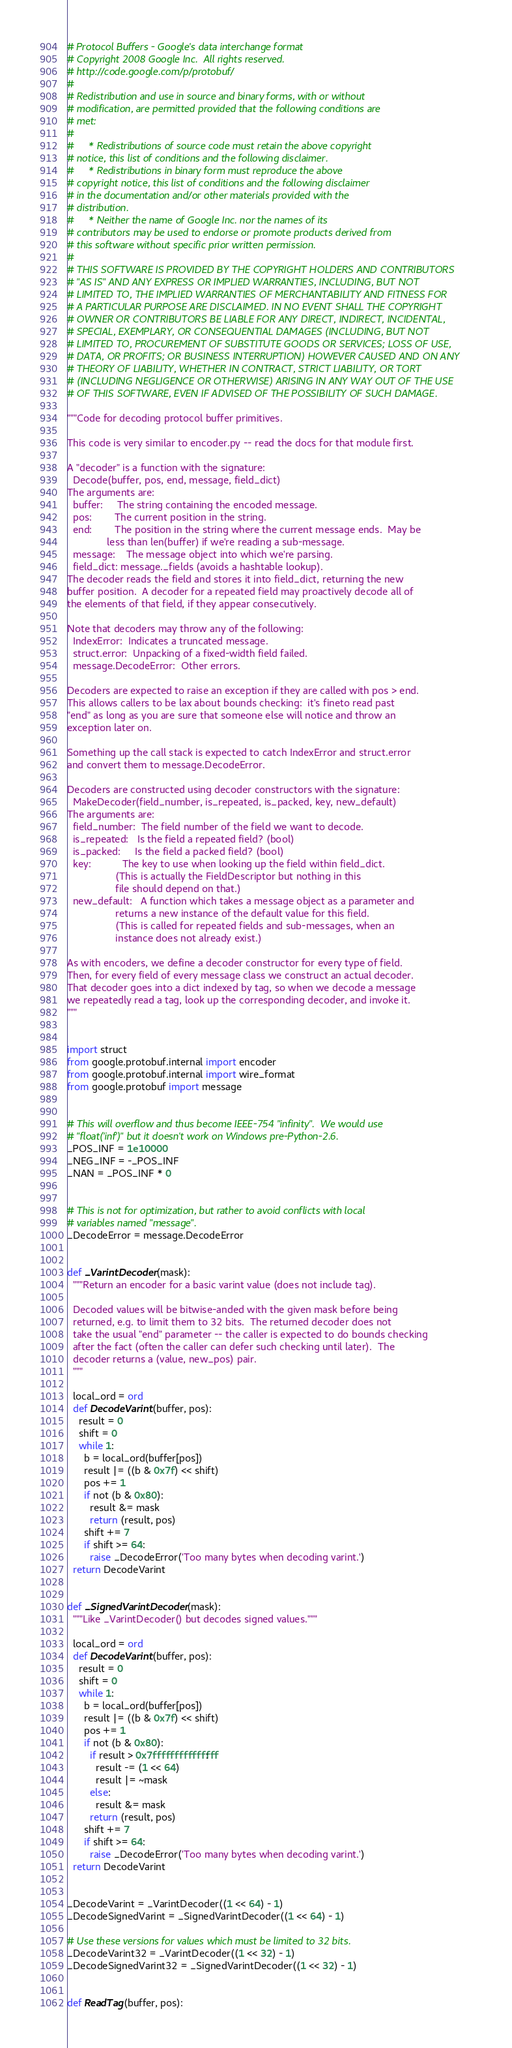Convert code to text. <code><loc_0><loc_0><loc_500><loc_500><_Python_># Protocol Buffers - Google's data interchange format
# Copyright 2008 Google Inc.  All rights reserved.
# http://code.google.com/p/protobuf/
#
# Redistribution and use in source and binary forms, with or without
# modification, are permitted provided that the following conditions are
# met:
#
#     * Redistributions of source code must retain the above copyright
# notice, this list of conditions and the following disclaimer.
#     * Redistributions in binary form must reproduce the above
# copyright notice, this list of conditions and the following disclaimer
# in the documentation and/or other materials provided with the
# distribution.
#     * Neither the name of Google Inc. nor the names of its
# contributors may be used to endorse or promote products derived from
# this software without specific prior written permission.
#
# THIS SOFTWARE IS PROVIDED BY THE COPYRIGHT HOLDERS AND CONTRIBUTORS
# "AS IS" AND ANY EXPRESS OR IMPLIED WARRANTIES, INCLUDING, BUT NOT
# LIMITED TO, THE IMPLIED WARRANTIES OF MERCHANTABILITY AND FITNESS FOR
# A PARTICULAR PURPOSE ARE DISCLAIMED. IN NO EVENT SHALL THE COPYRIGHT
# OWNER OR CONTRIBUTORS BE LIABLE FOR ANY DIRECT, INDIRECT, INCIDENTAL,
# SPECIAL, EXEMPLARY, OR CONSEQUENTIAL DAMAGES (INCLUDING, BUT NOT
# LIMITED TO, PROCUREMENT OF SUBSTITUTE GOODS OR SERVICES; LOSS OF USE,
# DATA, OR PROFITS; OR BUSINESS INTERRUPTION) HOWEVER CAUSED AND ON ANY
# THEORY OF LIABILITY, WHETHER IN CONTRACT, STRICT LIABILITY, OR TORT
# (INCLUDING NEGLIGENCE OR OTHERWISE) ARISING IN ANY WAY OUT OF THE USE
# OF THIS SOFTWARE, EVEN IF ADVISED OF THE POSSIBILITY OF SUCH DAMAGE.

"""Code for decoding protocol buffer primitives.

This code is very similar to encoder.py -- read the docs for that module first.

A "decoder" is a function with the signature:
  Decode(buffer, pos, end, message, field_dict)
The arguments are:
  buffer:     The string containing the encoded message.
  pos:        The current position in the string.
  end:        The position in the string where the current message ends.  May be
              less than len(buffer) if we're reading a sub-message.
  message:    The message object into which we're parsing.
  field_dict: message._fields (avoids a hashtable lookup).
The decoder reads the field and stores it into field_dict, returning the new
buffer position.  A decoder for a repeated field may proactively decode all of
the elements of that field, if they appear consecutively.

Note that decoders may throw any of the following:
  IndexError:  Indicates a truncated message.
  struct.error:  Unpacking of a fixed-width field failed.
  message.DecodeError:  Other errors.

Decoders are expected to raise an exception if they are called with pos > end.
This allows callers to be lax about bounds checking:  it's fineto read past
"end" as long as you are sure that someone else will notice and throw an
exception later on.

Something up the call stack is expected to catch IndexError and struct.error
and convert them to message.DecodeError.

Decoders are constructed using decoder constructors with the signature:
  MakeDecoder(field_number, is_repeated, is_packed, key, new_default)
The arguments are:
  field_number:  The field number of the field we want to decode.
  is_repeated:   Is the field a repeated field? (bool)
  is_packed:     Is the field a packed field? (bool)
  key:           The key to use when looking up the field within field_dict.
                 (This is actually the FieldDescriptor but nothing in this
                 file should depend on that.)
  new_default:   A function which takes a message object as a parameter and
                 returns a new instance of the default value for this field.
                 (This is called for repeated fields and sub-messages, when an
                 instance does not already exist.)

As with encoders, we define a decoder constructor for every type of field.
Then, for every field of every message class we construct an actual decoder.
That decoder goes into a dict indexed by tag, so when we decode a message
we repeatedly read a tag, look up the corresponding decoder, and invoke it.
"""


import struct
from google.protobuf.internal import encoder
from google.protobuf.internal import wire_format
from google.protobuf import message


# This will overflow and thus become IEEE-754 "infinity".  We would use
# "float('inf')" but it doesn't work on Windows pre-Python-2.6.
_POS_INF = 1e10000
_NEG_INF = -_POS_INF
_NAN = _POS_INF * 0


# This is not for optimization, but rather to avoid conflicts with local
# variables named "message".
_DecodeError = message.DecodeError


def _VarintDecoder(mask):
  """Return an encoder for a basic varint value (does not include tag).

  Decoded values will be bitwise-anded with the given mask before being
  returned, e.g. to limit them to 32 bits.  The returned decoder does not
  take the usual "end" parameter -- the caller is expected to do bounds checking
  after the fact (often the caller can defer such checking until later).  The
  decoder returns a (value, new_pos) pair.
  """

  local_ord = ord
  def DecodeVarint(buffer, pos):
    result = 0
    shift = 0
    while 1:
      b = local_ord(buffer[pos])
      result |= ((b & 0x7f) << shift)
      pos += 1
      if not (b & 0x80):
        result &= mask
        return (result, pos)
      shift += 7
      if shift >= 64:
        raise _DecodeError('Too many bytes when decoding varint.')
  return DecodeVarint


def _SignedVarintDecoder(mask):
  """Like _VarintDecoder() but decodes signed values."""

  local_ord = ord
  def DecodeVarint(buffer, pos):
    result = 0
    shift = 0
    while 1:
      b = local_ord(buffer[pos])
      result |= ((b & 0x7f) << shift)
      pos += 1
      if not (b & 0x80):
        if result > 0x7fffffffffffffff:
          result -= (1 << 64)
          result |= ~mask
        else:
          result &= mask
        return (result, pos)
      shift += 7
      if shift >= 64:
        raise _DecodeError('Too many bytes when decoding varint.')
  return DecodeVarint


_DecodeVarint = _VarintDecoder((1 << 64) - 1)
_DecodeSignedVarint = _SignedVarintDecoder((1 << 64) - 1)

# Use these versions for values which must be limited to 32 bits.
_DecodeVarint32 = _VarintDecoder((1 << 32) - 1)
_DecodeSignedVarint32 = _SignedVarintDecoder((1 << 32) - 1)


def ReadTag(buffer, pos):</code> 